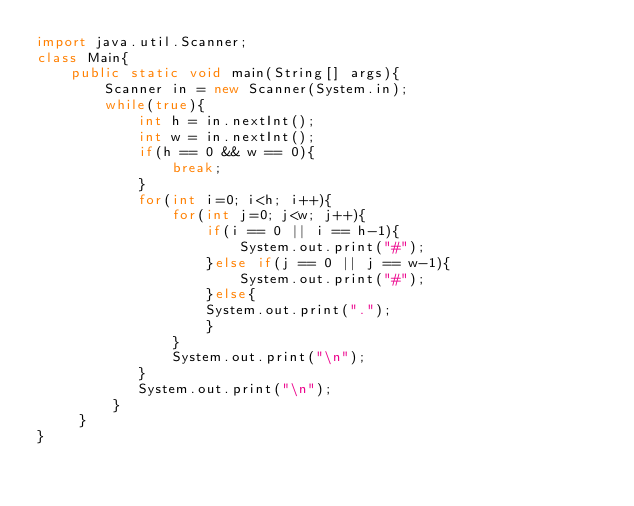Convert code to text. <code><loc_0><loc_0><loc_500><loc_500><_Java_>import java.util.Scanner;                                                                     
class Main{
    public static void main(String[] args){
        Scanner in = new Scanner(System.in);
        while(true){
            int h = in.nextInt();
            int w = in.nextInt();
            if(h == 0 && w == 0){
                break;
            }
            for(int i=0; i<h; i++){
                for(int j=0; j<w; j++){
                    if(i == 0 || i == h-1){
                        System.out.print("#");
                    }else if(j == 0 || j == w-1){
                        System.out.print("#");
                    }else{
                    System.out.print(".");
                    }
                }
                System.out.print("\n");
            }
            System.out.print("\n");
         }
     }
}               </code> 